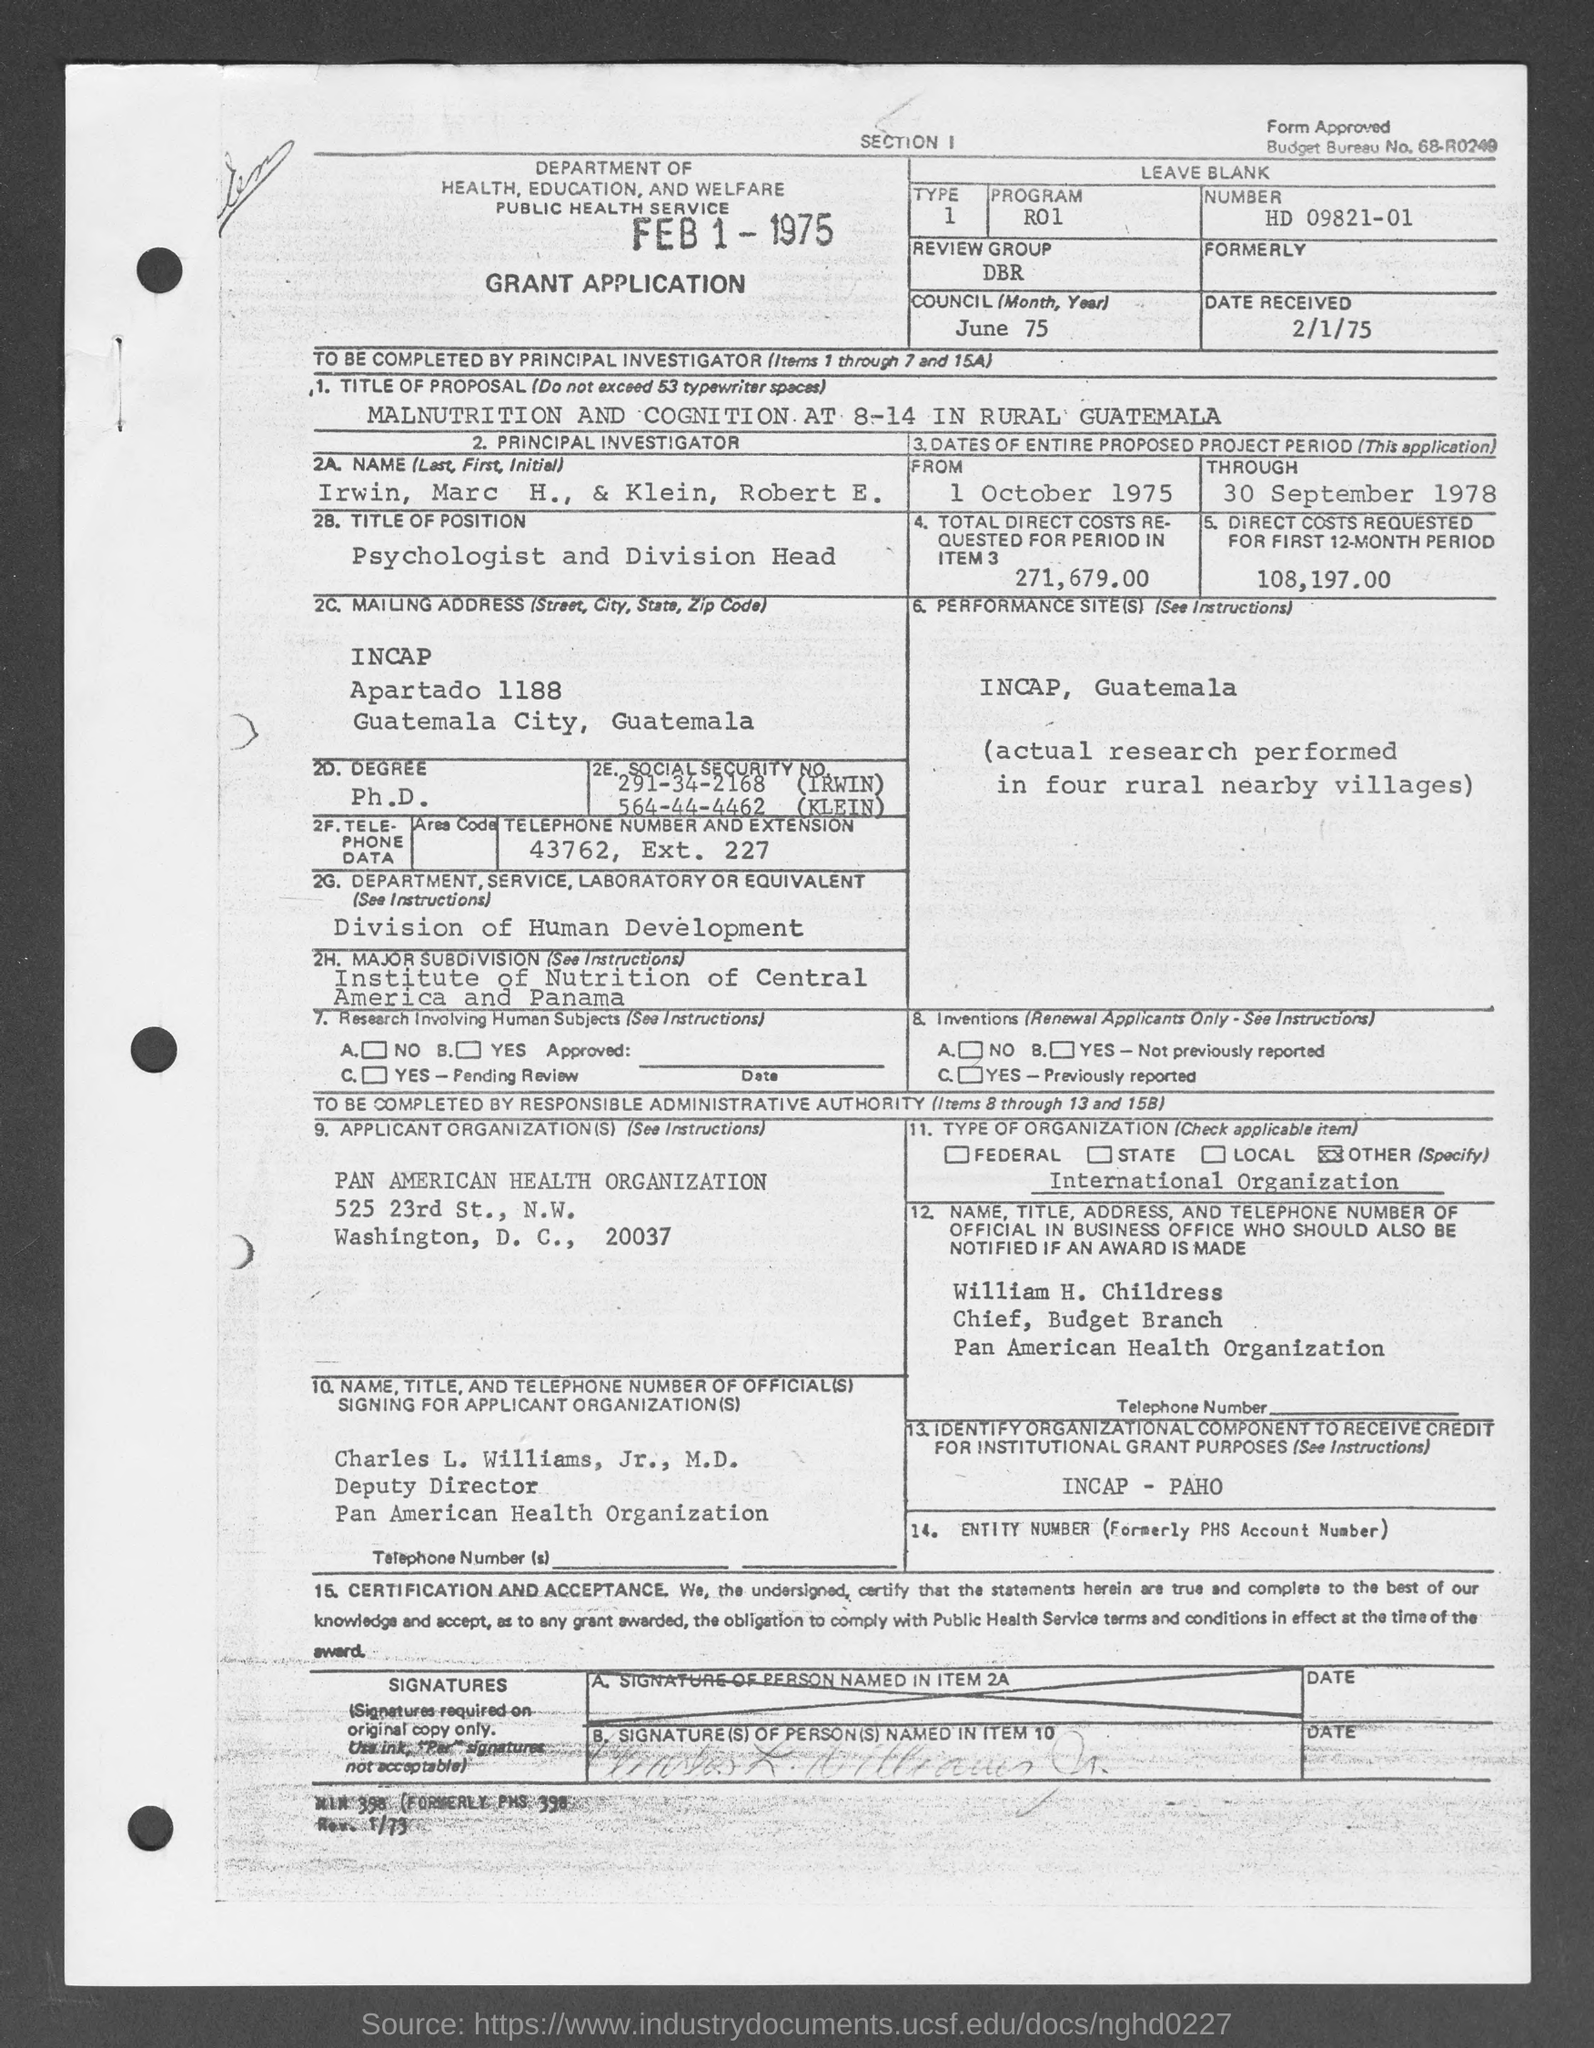What is the Program?
Make the answer very short. R01. What is the Number?
Give a very brief answer. HD 09821-01. What is the Review Group?
Provide a short and direct response. DBR. What is the Council?
Make the answer very short. June 75. What is the Date Received?
Your answer should be compact. 2/1/75. What is the Telephone number and extension?
Your answer should be compact. 43762, ext. 227. What is the total direct costs requested for period in Item 3?
Provide a short and direct response. 271,679.00. What is the "From" date?
Keep it short and to the point. 1 October 1975. What is the "Through" date?
Offer a terse response. 30 September 1978. 